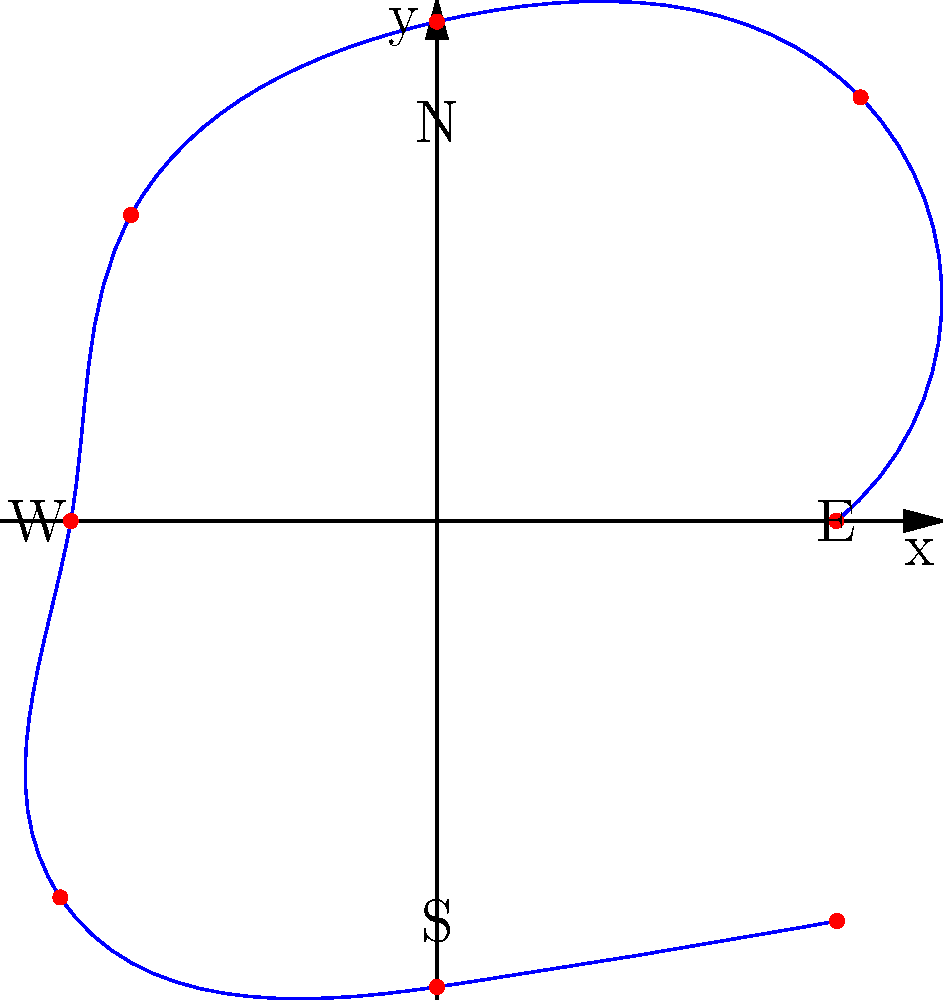As a motorsport enthusiast and mechanic, you're analyzing g-force data from a race car during a lap. The polar plot shows g-force measurements at 45-degree intervals around the track. If the maximum allowable g-force for the car's suspension is 1.7g, at which direction(s) is the suspension most stressed, and what could be causing this? To answer this question, we need to analyze the polar plot step-by-step:

1. The plot shows g-force measurements at 45-degree intervals (0°, 45°, 90°, 135°, 180°, 225°, 270°, 315°).

2. The radial distance from the center represents the magnitude of the g-force.

3. We need to identify the points where the g-force is closest to or exceeds 1.7g.

4. Examining the plot, we can see that there are two points where the g-force is very close to or at 1.7g:
   - At 45° (NE direction)
   - At 315° (NW direction)

5. These points correspond to left and right turns on the track, respectively.

6. The high g-forces at these points indicate that the car is experiencing significant lateral acceleration during cornering.

7. The suspension is most stressed at these points because it has to manage the weight transfer of the car during high-speed turns.

8. Possible causes for these high g-forces include:
   - Sharp turns or chicanes on the track
   - High-speed cornering
   - Aggressive driving style
   - Stiff suspension setup

9. As a mechanic, you might consider:
   - Adjusting the suspension settings to better handle these forces
   - Checking the suspension components for wear after each race
   - Advising the driver on smoother cornering techniques if necessary
Answer: NE (45°) and NW (315°) directions; caused by high-speed cornering. 